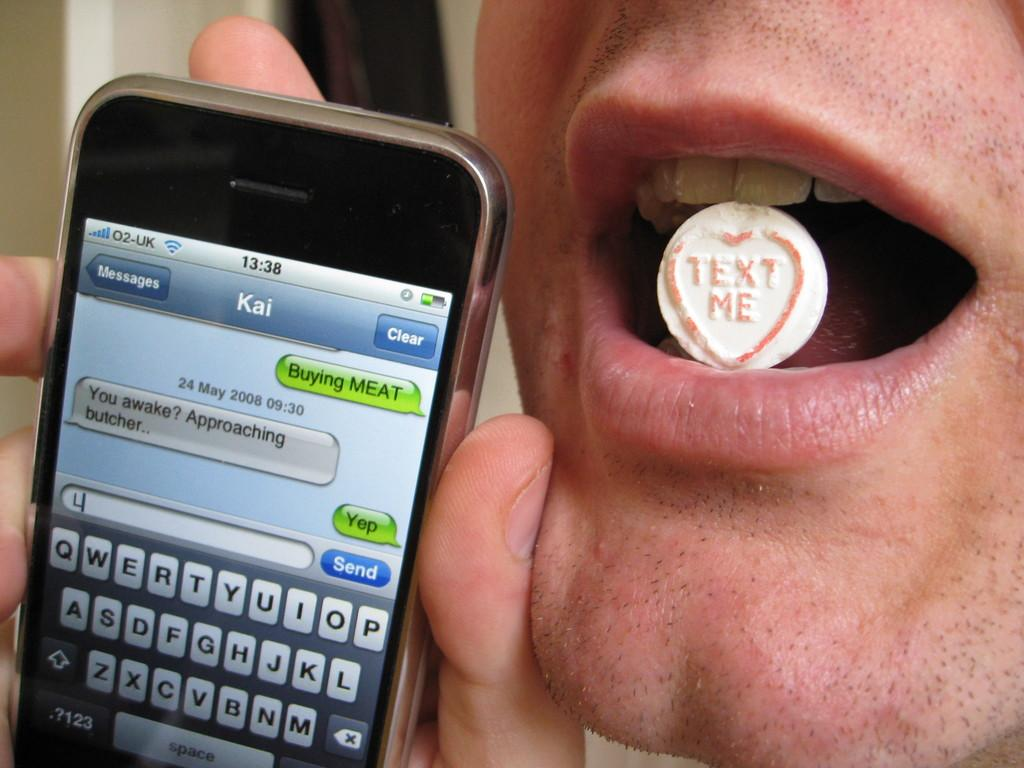<image>
Give a short and clear explanation of the subsequent image. A man with a piece of candy in his mouth with a red heart and the words Text Me. 